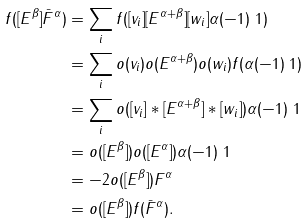Convert formula to latex. <formula><loc_0><loc_0><loc_500><loc_500>f ( [ E ^ { \beta } ] \bar { F } ^ { \alpha } ) & = \sum _ { i } f ( [ v _ { i } ] [ E ^ { \alpha + \beta } ] [ w _ { i } ] \alpha ( - 1 ) \ 1 ) \\ & = \sum _ { i } o ( v _ { i } ) o ( E ^ { \alpha + \beta } ) o ( w _ { i } ) f ( \alpha ( - 1 ) \ 1 ) \\ & = \sum _ { i } o ( [ v _ { i } ] * [ E ^ { \alpha + \beta } ] * [ w _ { i } ] ) \alpha ( - 1 ) \ 1 \\ & = o ( [ E ^ { \beta } ] ) o ( [ E ^ { \alpha } ] ) \alpha ( - 1 ) \ 1 \\ & = - 2 o ( [ E ^ { \beta } ] ) F ^ { \alpha } \\ & = o ( [ E ^ { \beta } ] ) f ( \bar { F } ^ { \alpha } ) .</formula> 